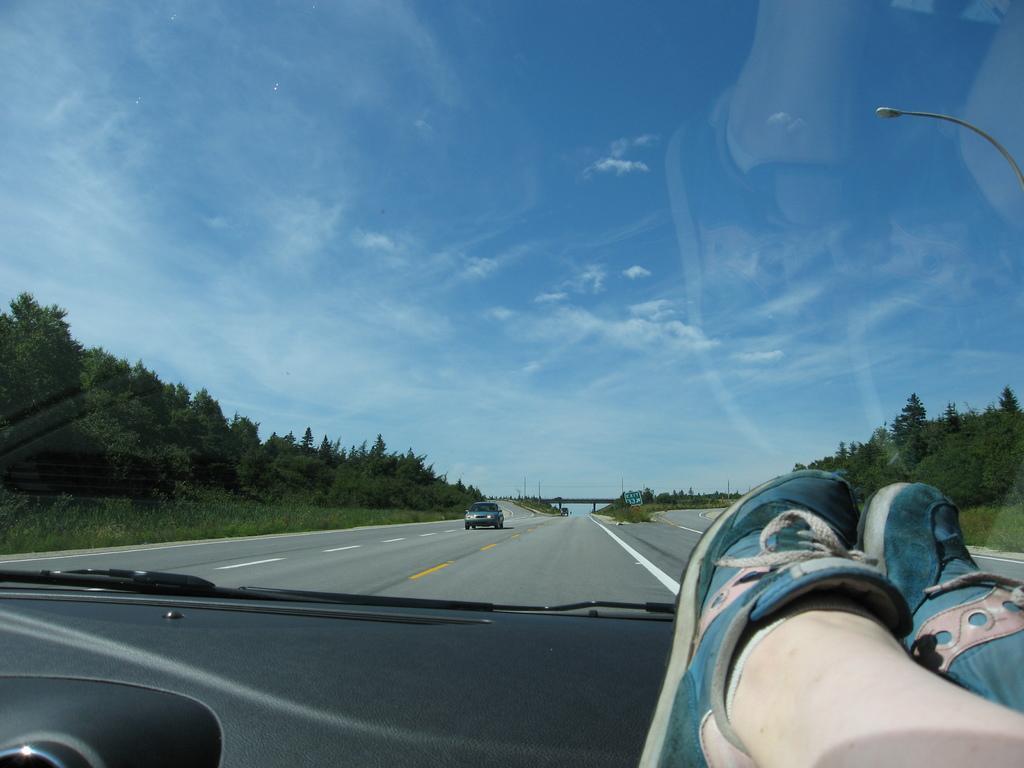Can you describe this image briefly? The picture is clicked inside a vehicle. On the road a car is moving. In the bottom right we can see two legs with shoes. On both side of the road there are trees. In the background we can see a bridge. The sky is cloudy. 